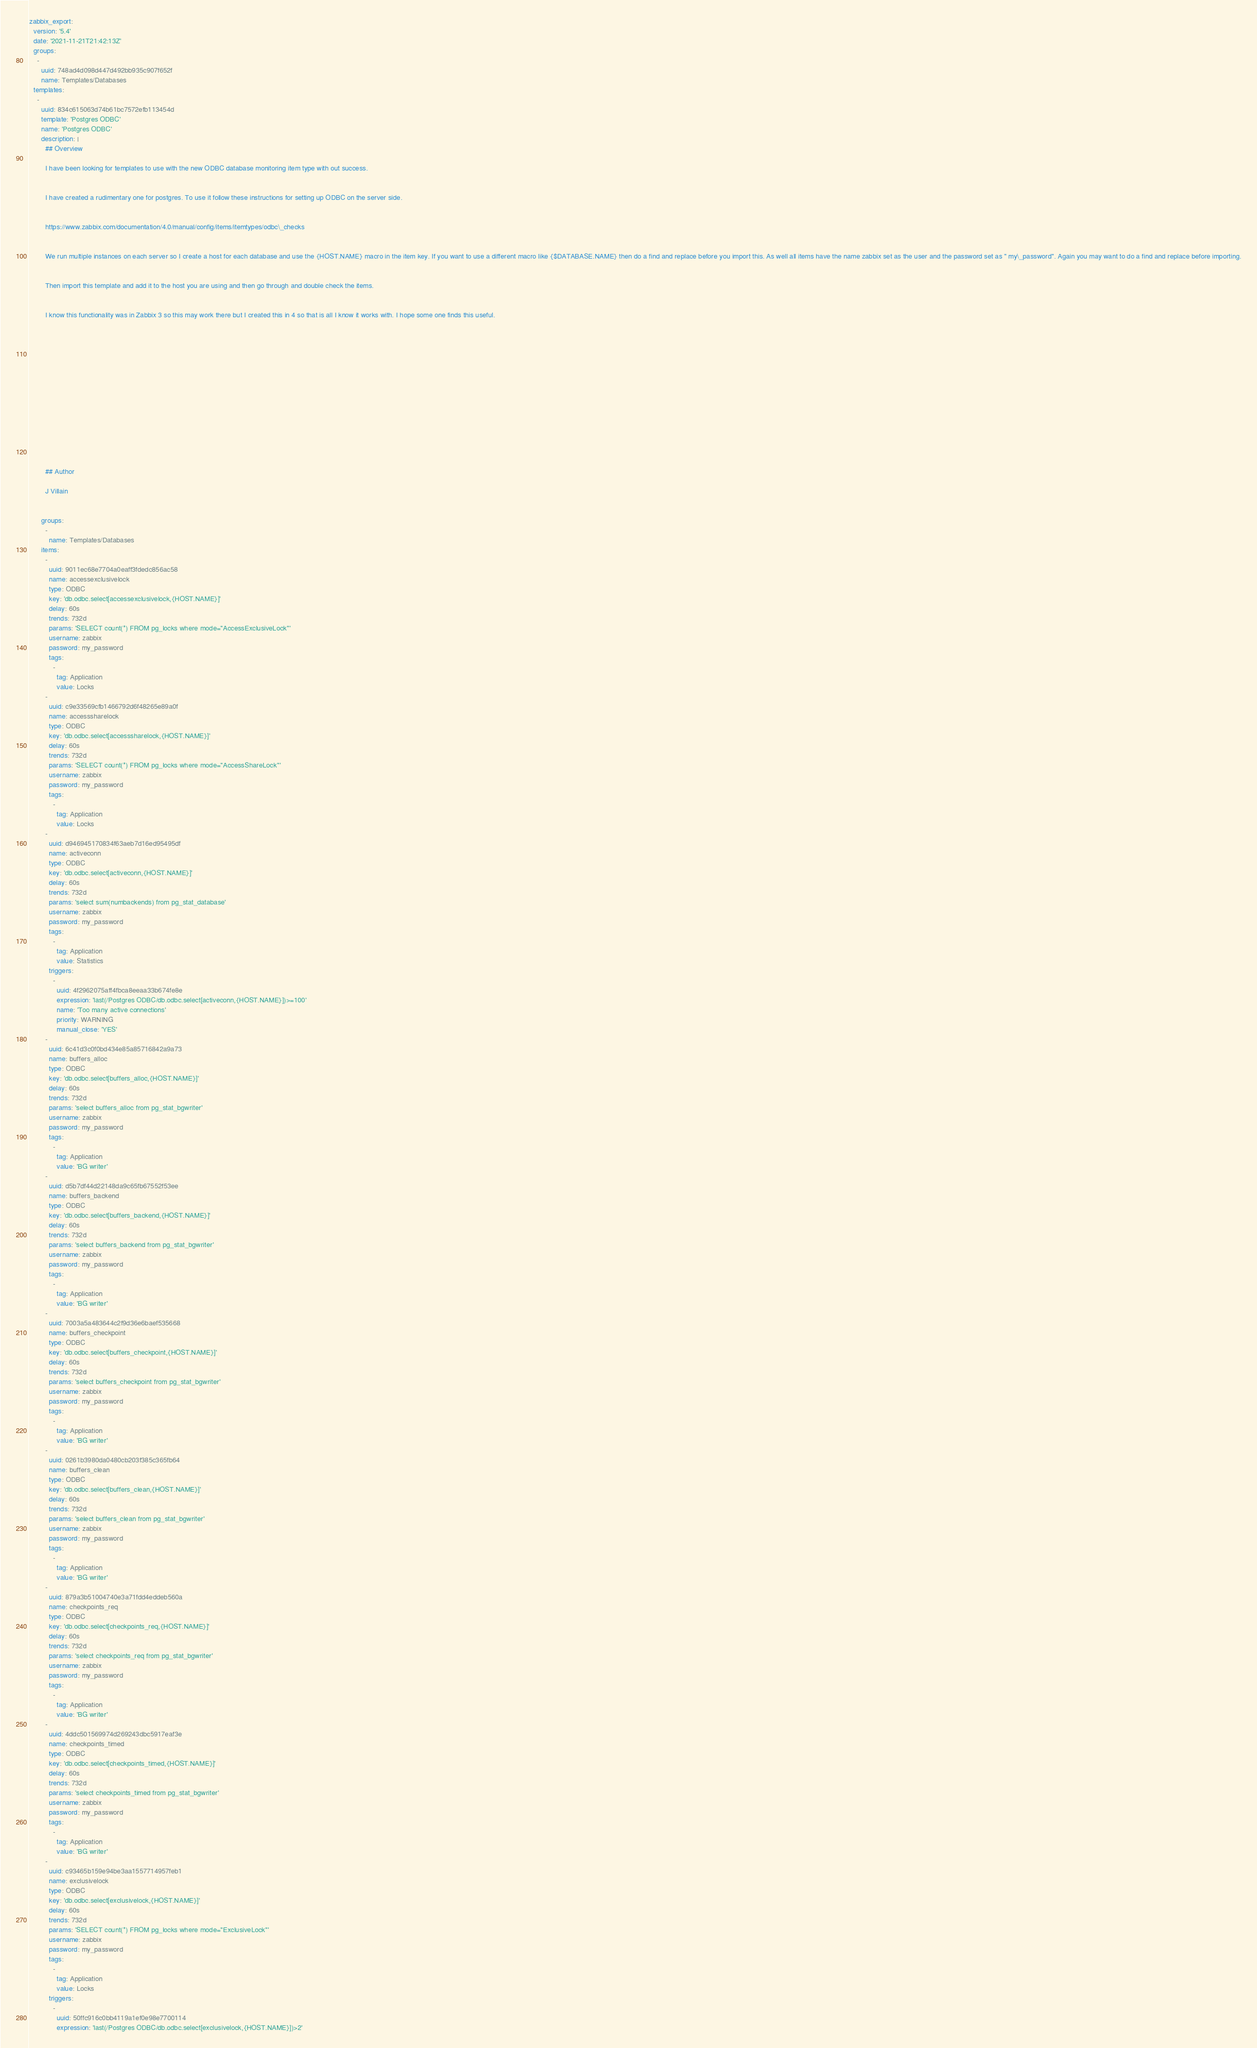Convert code to text. <code><loc_0><loc_0><loc_500><loc_500><_YAML_>zabbix_export:
  version: '5.4'
  date: '2021-11-21T21:42:13Z'
  groups:
    -
      uuid: 748ad4d098d447d492bb935c907f652f
      name: Templates/Databases
  templates:
    -
      uuid: 834c615063d74b61bc7572efb113454d
      template: 'Postgres ODBC'
      name: 'Postgres ODBC'
      description: |
        ## Overview
        
        I have been looking for templates to use with the new ODBC database monitoring item type with out success. 
        
        
        I have created a rudimentary one for postgres. To use it follow these instructions for setting up ODBC on the server side.
        
        
        https://www.zabbix.com/documentation/4.0/manual/config/items/itemtypes/odbc\_checks
        
        
        We run multiple instances on each server so I create a host for each database and use the {HOST.NAME} macro in the item key. If you want to use a different macro like {$DATABASE.NAME} then do a find and replace before you import this. As well all items have the name zabbix set as the user and the password set as " my\_password". Again you may want to do a find and replace before importing.
        
        
        Then import this template and add it to the host you are using and then go through and double check the items.
        
        
        I know this functionality was in Zabbix 3 so this may work there but I created this in 4 so that is all I know it works with. I hope some one finds this useful.
        
        
         
        
        
         
        
        
         
        
        
         
        
        
        
        ## Author
        
        J Villain
        
        
      groups:
        -
          name: Templates/Databases
      items:
        -
          uuid: 9011ec68e7704a0eaff3fdedc856ac58
          name: accessexclusivelock
          type: ODBC
          key: 'db.odbc.select[accessexclusivelock,{HOST.NAME}]'
          delay: 60s
          trends: 732d
          params: 'SELECT count(*) FROM pg_locks where mode=''AccessExclusiveLock'''
          username: zabbix
          password: my_password
          tags:
            -
              tag: Application
              value: Locks
        -
          uuid: c9e33569cfb1466792d6f48265e89a0f
          name: accesssharelock
          type: ODBC
          key: 'db.odbc.select[accesssharelock,{HOST.NAME}]'
          delay: 60s
          trends: 732d
          params: 'SELECT count(*) FROM pg_locks where mode=''AccessShareLock'''
          username: zabbix
          password: my_password
          tags:
            -
              tag: Application
              value: Locks
        -
          uuid: d946945170834f63aeb7d16ed95495df
          name: activeconn
          type: ODBC
          key: 'db.odbc.select[activeconn,{HOST.NAME}]'
          delay: 60s
          trends: 732d
          params: 'select sum(numbackends) from pg_stat_database'
          username: zabbix
          password: my_password
          tags:
            -
              tag: Application
              value: Statistics
          triggers:
            -
              uuid: 4f2962075aff4fbca8eeaa33b674fe8e
              expression: 'last(/Postgres ODBC/db.odbc.select[activeconn,{HOST.NAME}])>=100'
              name: 'Too many active connections'
              priority: WARNING
              manual_close: 'YES'
        -
          uuid: 6c41d3c0f0bd434e85a85716842a9a73
          name: buffers_alloc
          type: ODBC
          key: 'db.odbc.select[buffers_alloc,{HOST.NAME}]'
          delay: 60s
          trends: 732d
          params: 'select buffers_alloc from pg_stat_bgwriter'
          username: zabbix
          password: my_password
          tags:
            -
              tag: Application
              value: 'BG writer'
        -
          uuid: d5b7df44d22148da9c65fb67552f53ee
          name: buffers_backend
          type: ODBC
          key: 'db.odbc.select[buffers_backend,{HOST.NAME}]'
          delay: 60s
          trends: 732d
          params: 'select buffers_backend from pg_stat_bgwriter'
          username: zabbix
          password: my_password
          tags:
            -
              tag: Application
              value: 'BG writer'
        -
          uuid: 7003a5a483644c2f9d36e6baef535668
          name: buffers_checkpoint
          type: ODBC
          key: 'db.odbc.select[buffers_checkpoint,{HOST.NAME}]'
          delay: 60s
          trends: 732d
          params: 'select buffers_checkpoint from pg_stat_bgwriter'
          username: zabbix
          password: my_password
          tags:
            -
              tag: Application
              value: 'BG writer'
        -
          uuid: 0261b3980da0480cb203f385c365fb64
          name: buffers_clean
          type: ODBC
          key: 'db.odbc.select[buffers_clean,{HOST.NAME}]'
          delay: 60s
          trends: 732d
          params: 'select buffers_clean from pg_stat_bgwriter'
          username: zabbix
          password: my_password
          tags:
            -
              tag: Application
              value: 'BG writer'
        -
          uuid: 879a3b51004740e3a71fdd4eddeb560a
          name: checkpoints_req
          type: ODBC
          key: 'db.odbc.select[checkpoints_req,{HOST.NAME}]'
          delay: 60s
          trends: 732d
          params: 'select checkpoints_req from pg_stat_bgwriter'
          username: zabbix
          password: my_password
          tags:
            -
              tag: Application
              value: 'BG writer'
        -
          uuid: 4ddc501569974d269243dbc5917eaf3e
          name: checkpoints_timed
          type: ODBC
          key: 'db.odbc.select[checkpoints_timed,{HOST.NAME}]'
          delay: 60s
          trends: 732d
          params: 'select checkpoints_timed from pg_stat_bgwriter'
          username: zabbix
          password: my_password
          tags:
            -
              tag: Application
              value: 'BG writer'
        -
          uuid: c93465b159e94be3aa1557714957feb1
          name: exclusivelock
          type: ODBC
          key: 'db.odbc.select[exclusivelock,{HOST.NAME}]'
          delay: 60s
          trends: 732d
          params: 'SELECT count(*) FROM pg_locks where mode=''ExclusiveLock'''
          username: zabbix
          password: my_password
          tags:
            -
              tag: Application
              value: Locks
          triggers:
            -
              uuid: 50ffc916c0bb4119a1ef0e98e7700114
              expression: 'last(/Postgres ODBC/db.odbc.select[exclusivelock,{HOST.NAME}])>2'</code> 